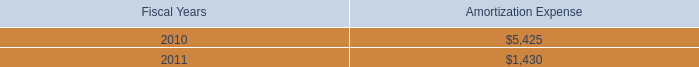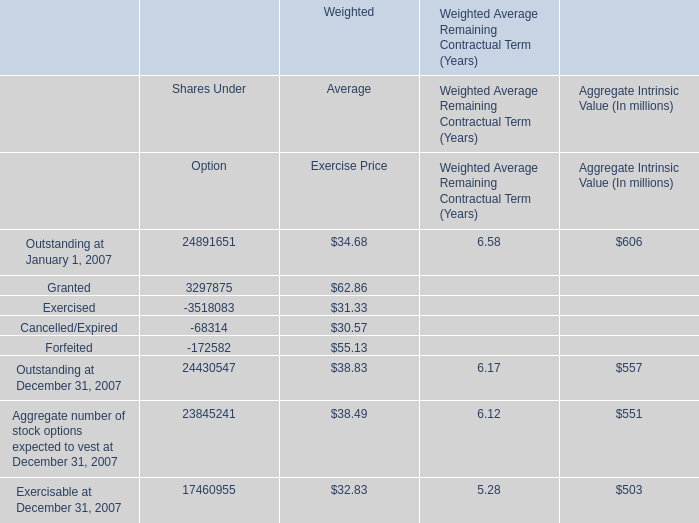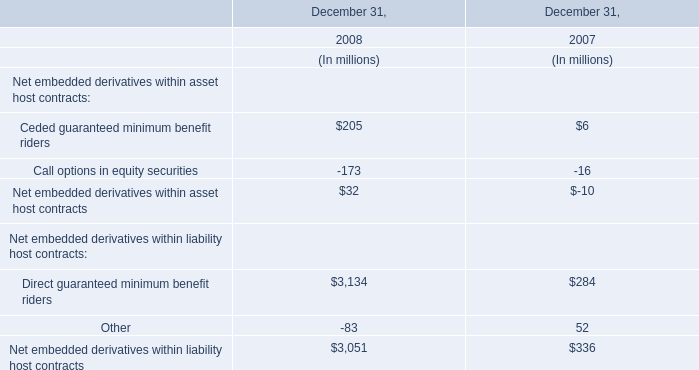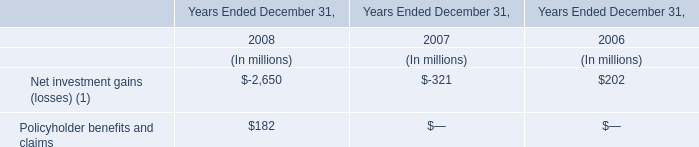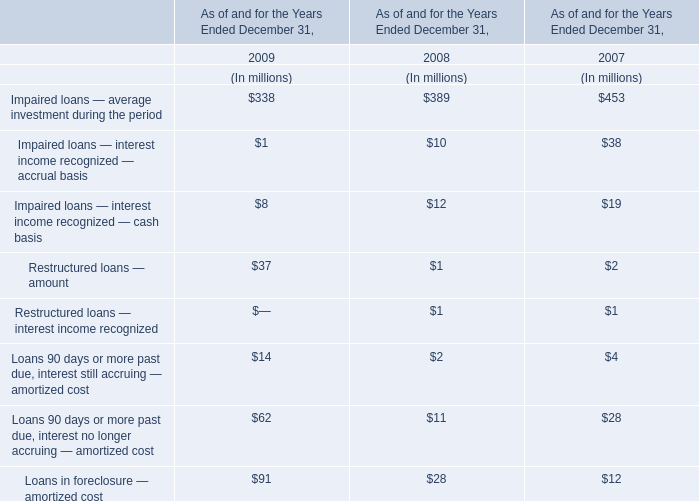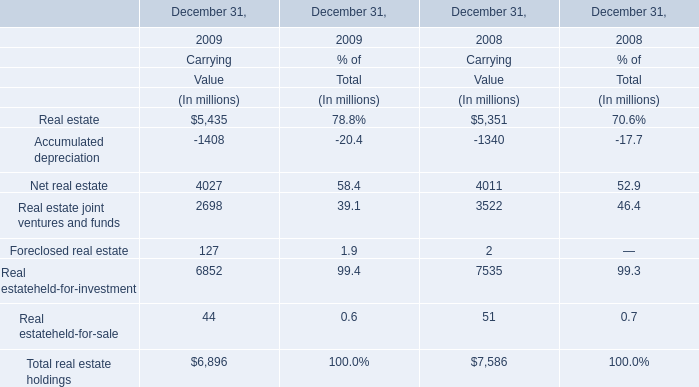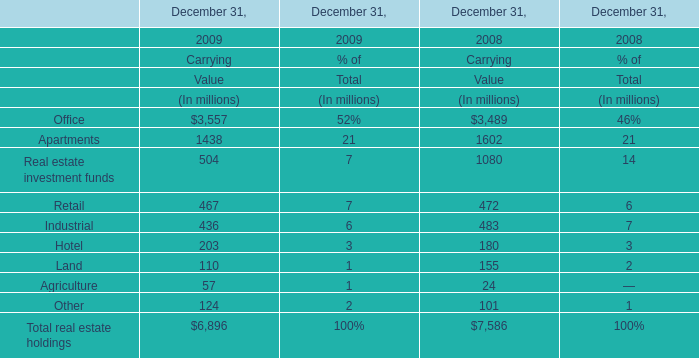When does Impaired loans — average investment during the period reach the largest value? 
Answer: 2007. 